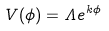<formula> <loc_0><loc_0><loc_500><loc_500>V ( \phi ) = \Lambda e ^ { k \phi }</formula> 